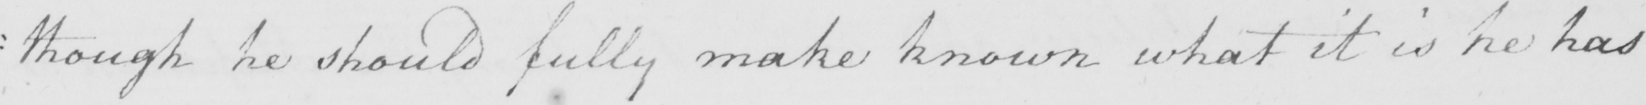What is written in this line of handwriting? : though he should fully make known what it is he has 